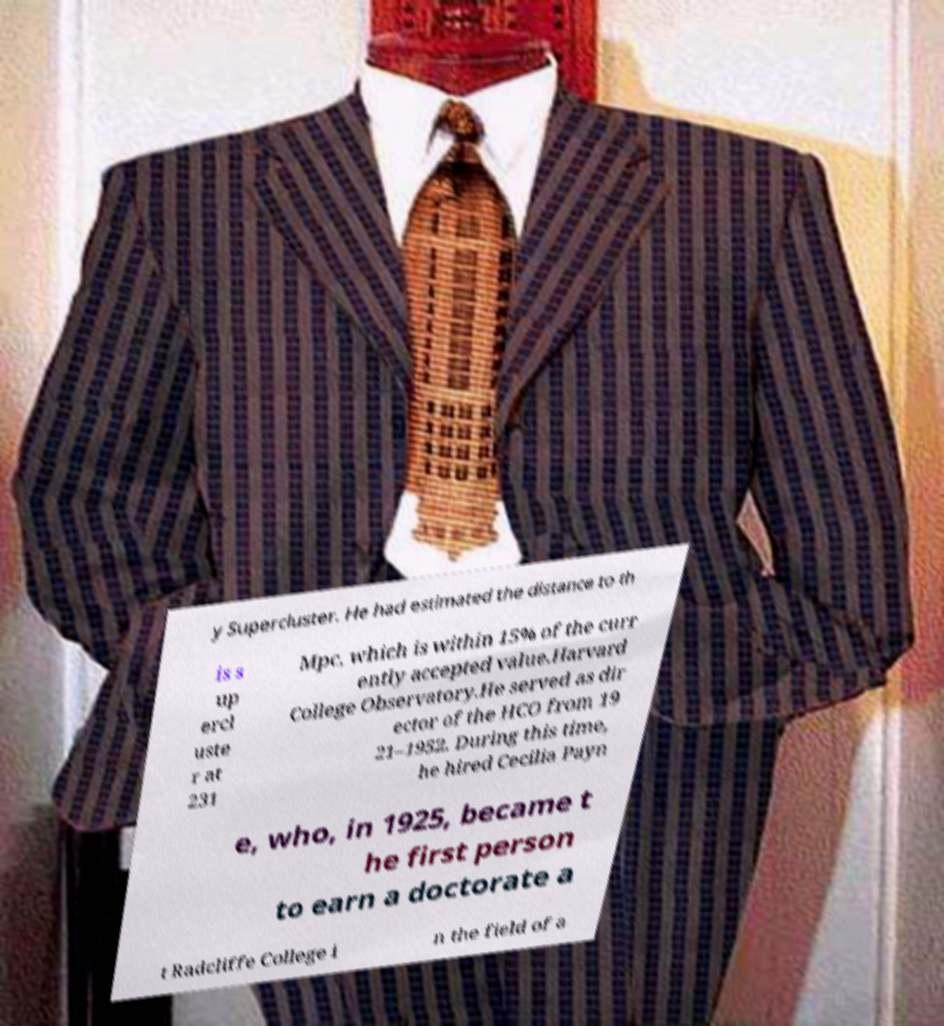Please read and relay the text visible in this image. What does it say? y Supercluster. He had estimated the distance to th is s up ercl uste r at 231 Mpc, which is within 15% of the curr ently accepted value.Harvard College Observatory.He served as dir ector of the HCO from 19 21–1952. During this time, he hired Cecilia Payn e, who, in 1925, became t he first person to earn a doctorate a t Radcliffe College i n the field of a 